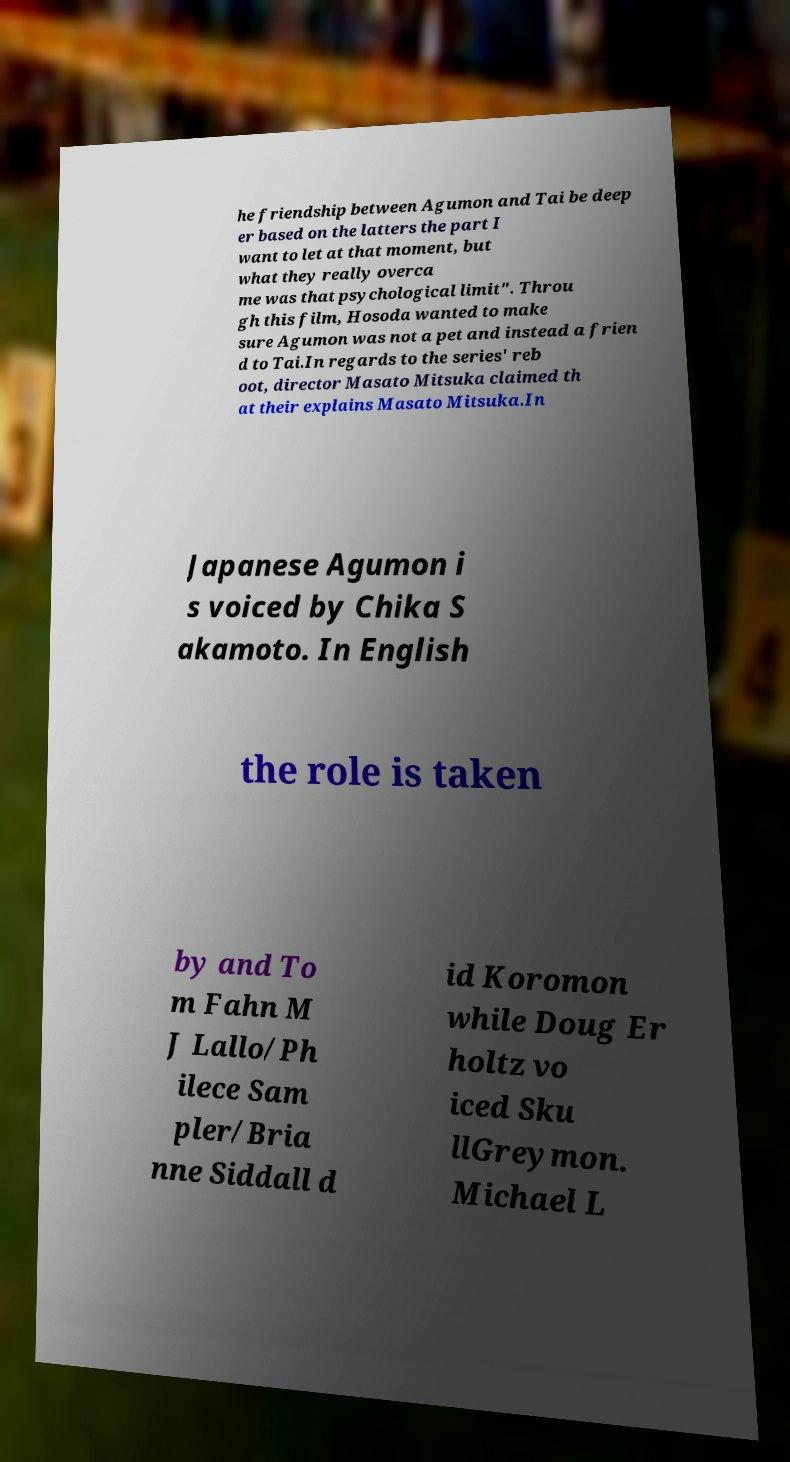Please read and relay the text visible in this image. What does it say? he friendship between Agumon and Tai be deep er based on the latters the part I want to let at that moment, but what they really overca me was that psychological limit". Throu gh this film, Hosoda wanted to make sure Agumon was not a pet and instead a frien d to Tai.In regards to the series' reb oot, director Masato Mitsuka claimed th at their explains Masato Mitsuka.In Japanese Agumon i s voiced by Chika S akamoto. In English the role is taken by and To m Fahn M J Lallo/Ph ilece Sam pler/Bria nne Siddall d id Koromon while Doug Er holtz vo iced Sku llGreymon. Michael L 